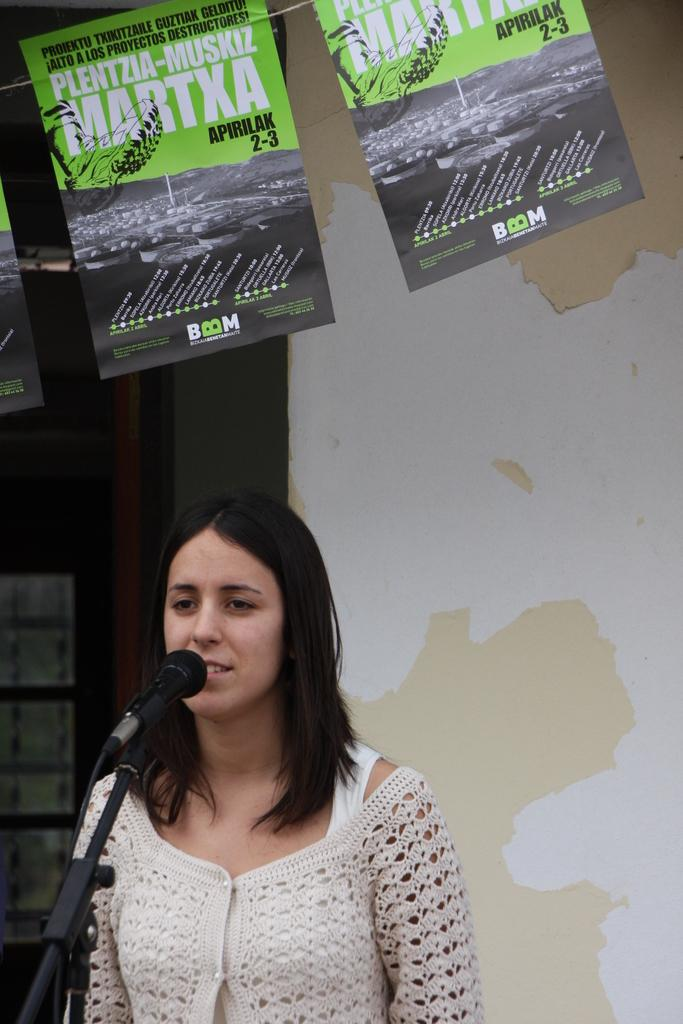Who is the main subject in the foreground of the image? There is a woman in the foreground of the image. What is the woman doing in the image? The woman is standing in front of a microphone. What can be seen in the background of the image? There is a wall and posters in the background of the image. When was the image taken? The image was taken during the day. Where is the store located in the image? There is no store present in the image. What type of magic is the woman performing in front of the microphone? There is no magic being performed in the image; the woman is simply standing in front of a microphone. 